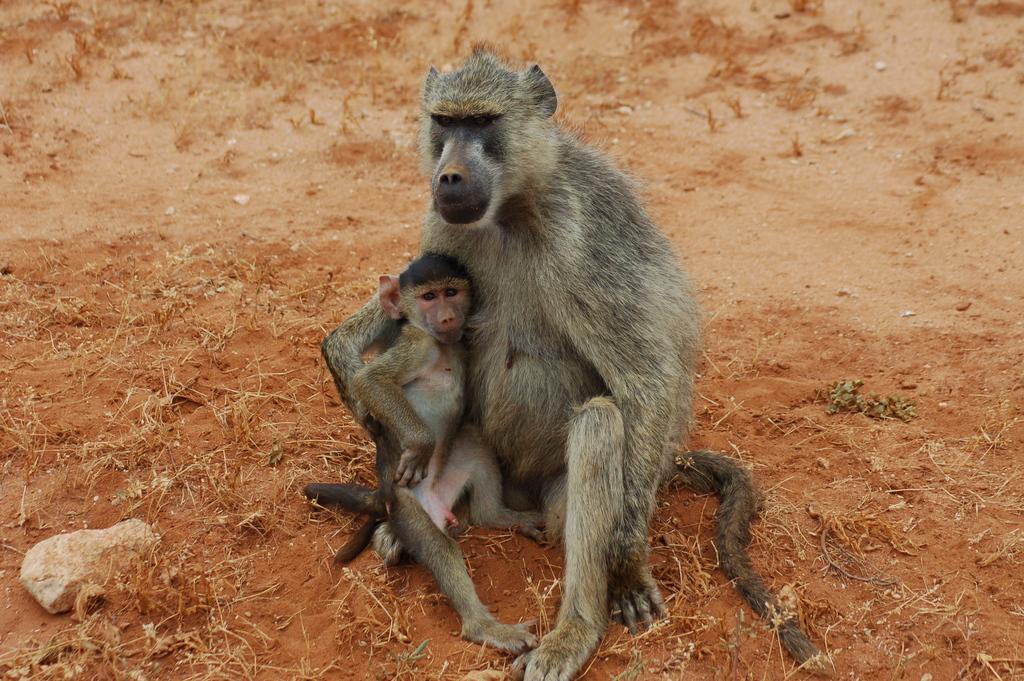Describe this image in one or two sentences. In this image there is a monkey sitting on the ground. There is a baby monkey in its arms. To the left there is a stone on the ground. 